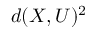Convert formula to latex. <formula><loc_0><loc_0><loc_500><loc_500>d ( X , U ) ^ { 2 }</formula> 